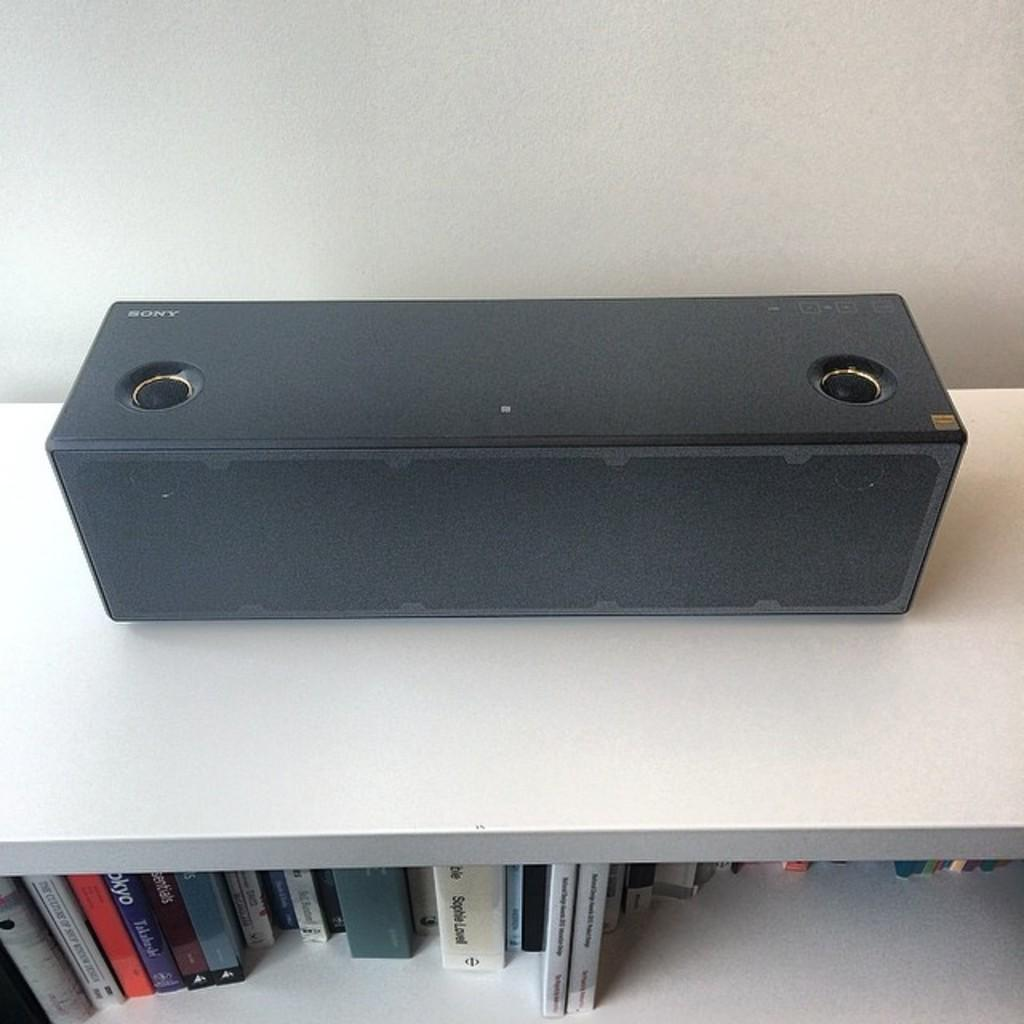What type of objects can be seen in the shelves at the bottom of the image? There are books in the shelves at the bottom of the image. What can be found in the middle of the image? There is a sound bar in the middle of the image. How many chickens are visible in the image? There are no chickens present in the image. What type of word is being used in the image? There is no specific word being used in the image; it features books, shelves, and a sound bar. 